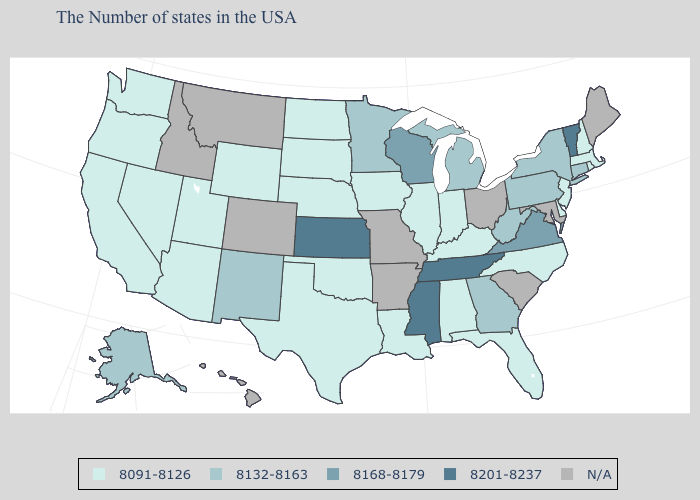Does the map have missing data?
Give a very brief answer. Yes. Which states hav the highest value in the South?
Short answer required. Tennessee, Mississippi. What is the value of Utah?
Keep it brief. 8091-8126. What is the value of New Mexico?
Be succinct. 8132-8163. Name the states that have a value in the range 8168-8179?
Be succinct. Virginia, Wisconsin. What is the lowest value in states that border West Virginia?
Keep it brief. 8091-8126. What is the lowest value in the South?
Be succinct. 8091-8126. What is the lowest value in the USA?
Concise answer only. 8091-8126. What is the highest value in the USA?
Write a very short answer. 8201-8237. What is the value of Nebraska?
Concise answer only. 8091-8126. Name the states that have a value in the range 8168-8179?
Concise answer only. Virginia, Wisconsin. Among the states that border New York , which have the highest value?
Write a very short answer. Vermont. Which states have the lowest value in the MidWest?
Give a very brief answer. Indiana, Illinois, Iowa, Nebraska, South Dakota, North Dakota. Name the states that have a value in the range 8201-8237?
Keep it brief. Vermont, Tennessee, Mississippi, Kansas. 